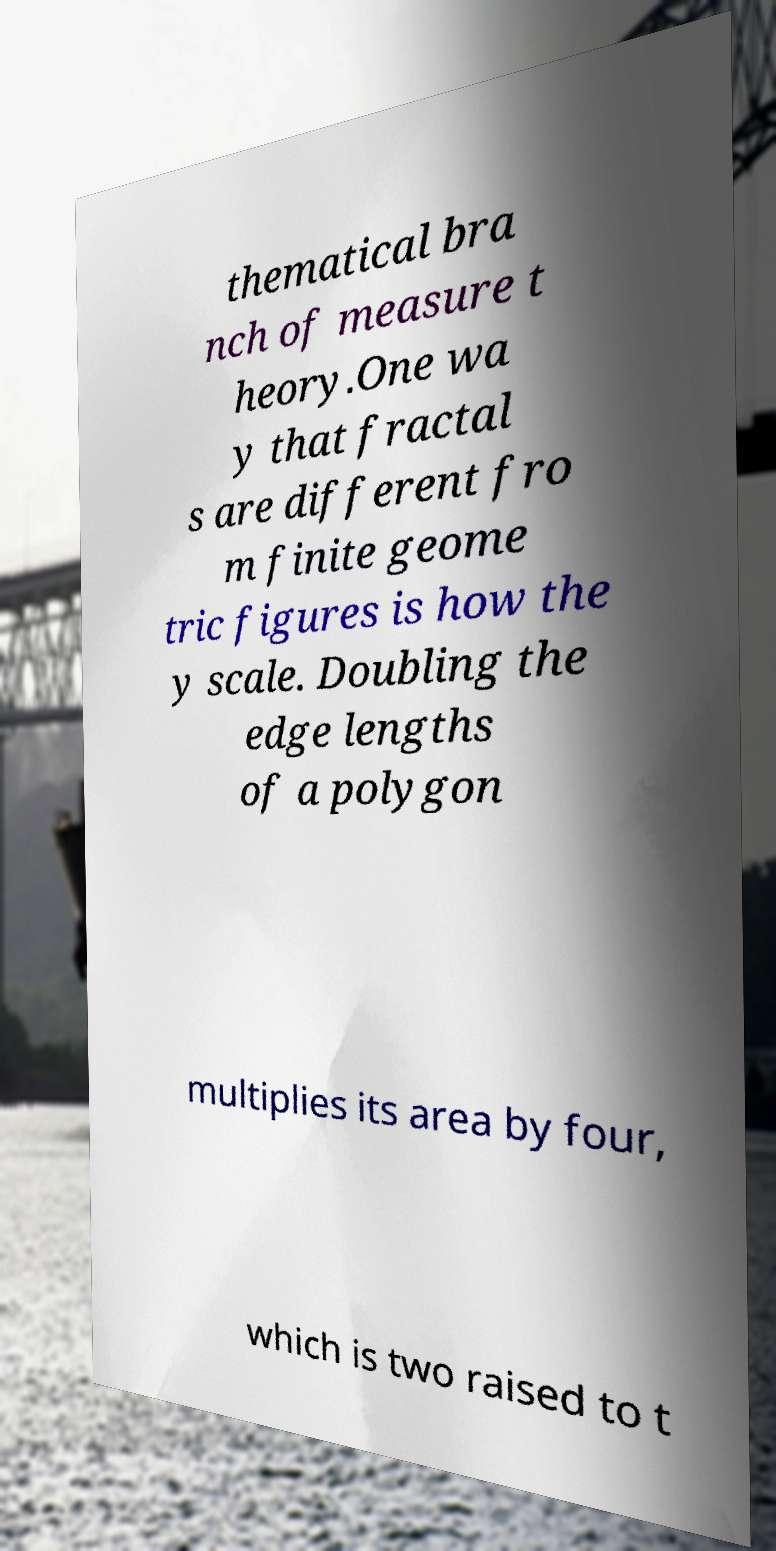Can you accurately transcribe the text from the provided image for me? thematical bra nch of measure t heory.One wa y that fractal s are different fro m finite geome tric figures is how the y scale. Doubling the edge lengths of a polygon multiplies its area by four, which is two raised to t 